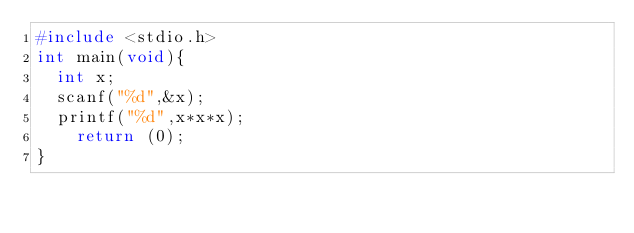<code> <loc_0><loc_0><loc_500><loc_500><_C_>#include <stdio.h>
int main(void){
	int x;
	scanf("%d",&x);
	printf("%d",x*x*x);
    return (0);
}</code> 